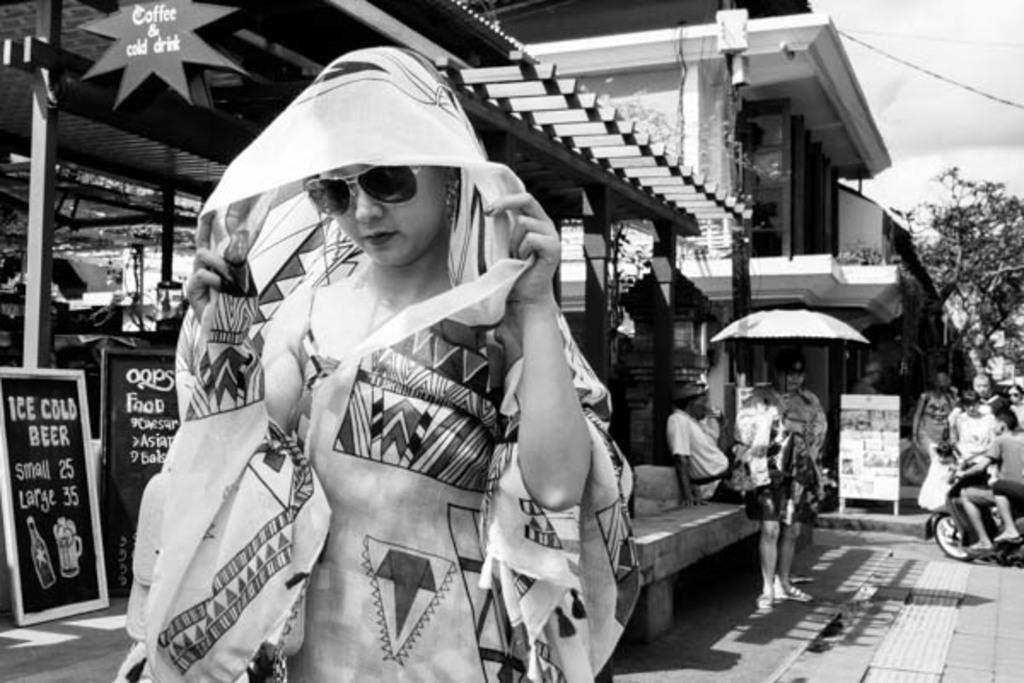Can you describe this image briefly? This is a black and white image. In the front of the image there is a lady standing. And in the background there are few people. And also there are building and poles. And there is a board with menu. 